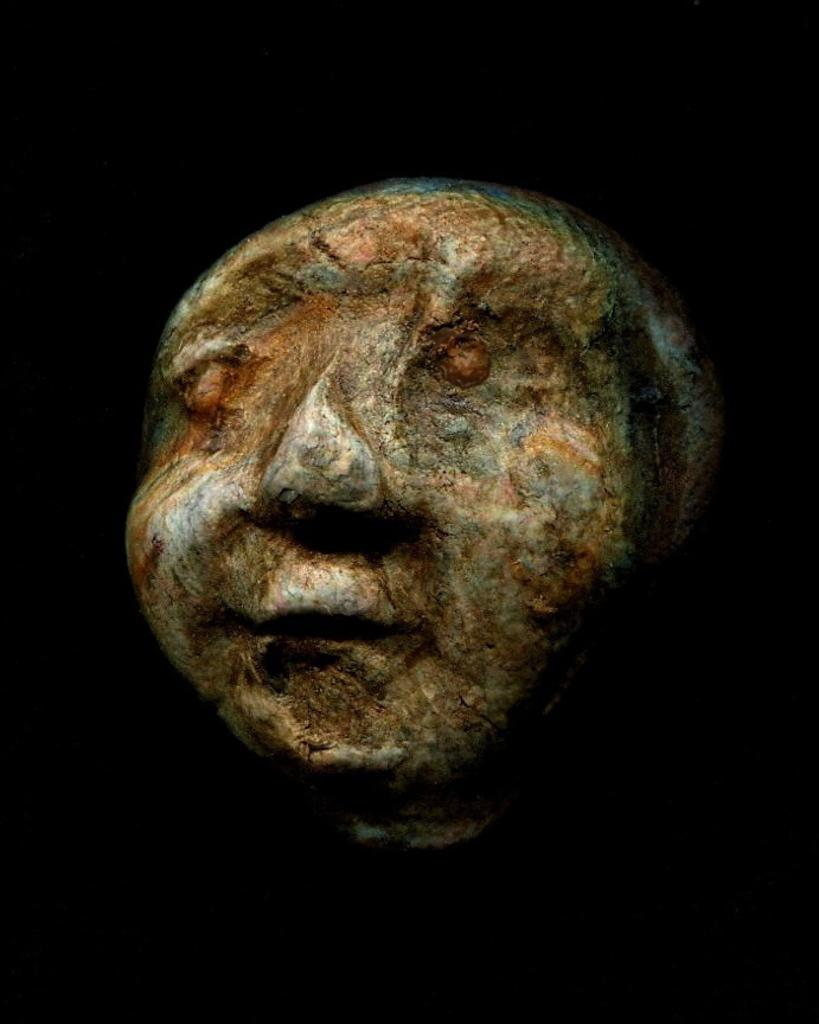What is the main subject of the image? There is a stone sculpture of a man's face in the image. What can be observed about the background of the image? The background of the image is black. What type of yam is being cooked in the image? There is no yam present in the image; it features a stone sculpture of a man's face with a black background. Can you describe the brain activity of the man in the image? There is no brain present in the image, as it is a stone sculpture of a man's face. 